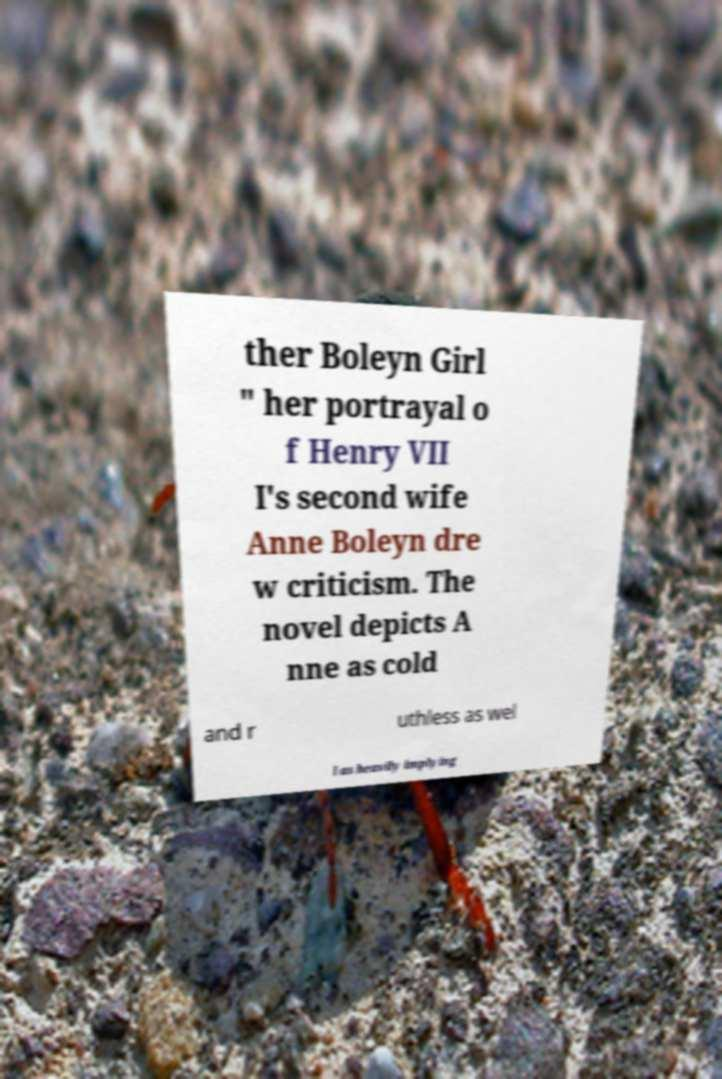For documentation purposes, I need the text within this image transcribed. Could you provide that? ther Boleyn Girl " her portrayal o f Henry VII I's second wife Anne Boleyn dre w criticism. The novel depicts A nne as cold and r uthless as wel l as heavily implying 